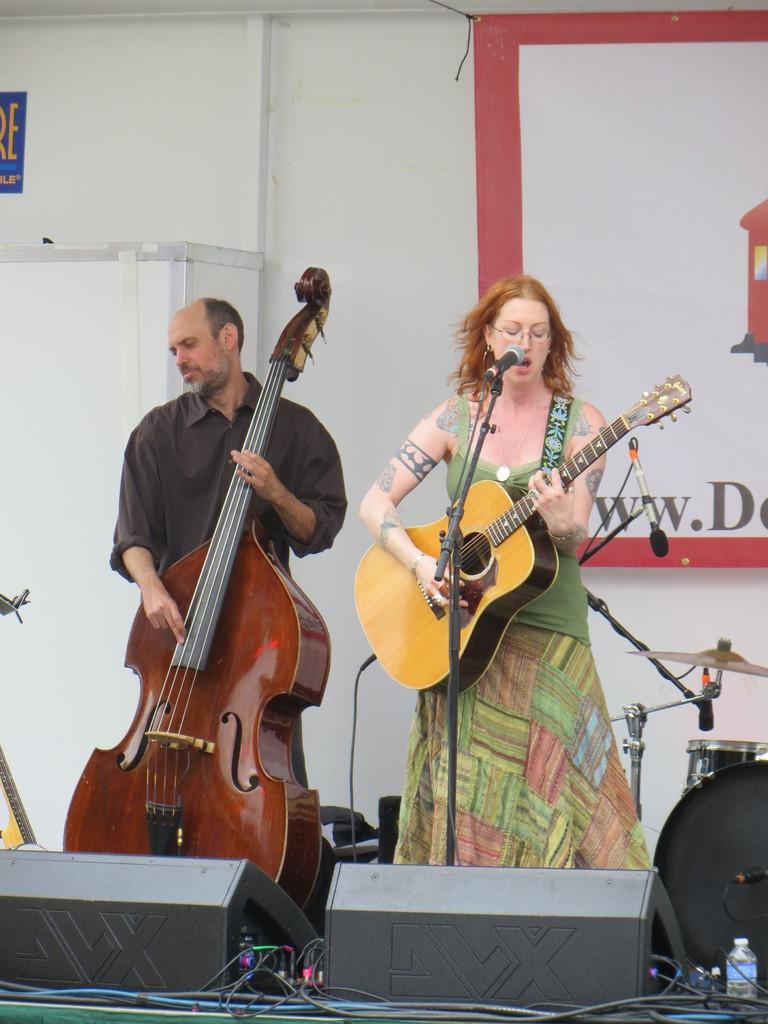What is the man in the image doing? The man is standing and playing a violin. What is the woman in the image doing? The woman is singing and playing a guitar while using a microphone. How many instruments can be seen in the image? Two instruments can be seen in the image: a violin and a guitar. What type of jewel is the woman wearing on her skirt in the image? There is no mention of a jewel or a skirt in the image; the woman is playing a guitar and using a microphone. 